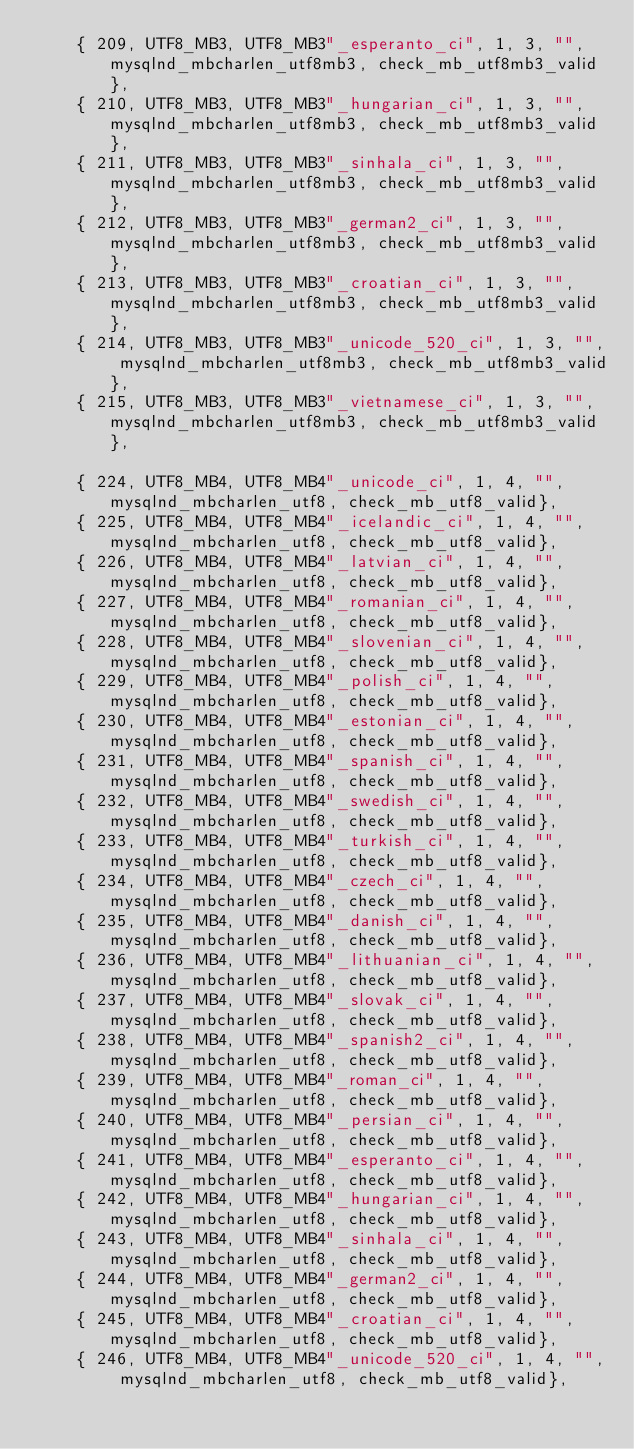Convert code to text. <code><loc_0><loc_0><loc_500><loc_500><_C_>	{ 209, UTF8_MB3, UTF8_MB3"_esperanto_ci", 1, 3, "", mysqlnd_mbcharlen_utf8mb3, check_mb_utf8mb3_valid},
	{ 210, UTF8_MB3, UTF8_MB3"_hungarian_ci", 1, 3, "", mysqlnd_mbcharlen_utf8mb3, check_mb_utf8mb3_valid},
	{ 211, UTF8_MB3, UTF8_MB3"_sinhala_ci", 1, 3, "", mysqlnd_mbcharlen_utf8mb3, check_mb_utf8mb3_valid},
	{ 212, UTF8_MB3, UTF8_MB3"_german2_ci", 1, 3, "", mysqlnd_mbcharlen_utf8mb3, check_mb_utf8mb3_valid},
	{ 213, UTF8_MB3, UTF8_MB3"_croatian_ci", 1, 3, "", mysqlnd_mbcharlen_utf8mb3, check_mb_utf8mb3_valid},
	{ 214, UTF8_MB3, UTF8_MB3"_unicode_520_ci", 1, 3, "", mysqlnd_mbcharlen_utf8mb3, check_mb_utf8mb3_valid},
	{ 215, UTF8_MB3, UTF8_MB3"_vietnamese_ci", 1, 3, "", mysqlnd_mbcharlen_utf8mb3, check_mb_utf8mb3_valid},

	{ 224, UTF8_MB4, UTF8_MB4"_unicode_ci", 1, 4, "", mysqlnd_mbcharlen_utf8, check_mb_utf8_valid},
	{ 225, UTF8_MB4, UTF8_MB4"_icelandic_ci", 1, 4, "", mysqlnd_mbcharlen_utf8, check_mb_utf8_valid},
	{ 226, UTF8_MB4, UTF8_MB4"_latvian_ci", 1, 4, "", mysqlnd_mbcharlen_utf8, check_mb_utf8_valid},
	{ 227, UTF8_MB4, UTF8_MB4"_romanian_ci", 1, 4, "", mysqlnd_mbcharlen_utf8, check_mb_utf8_valid},
	{ 228, UTF8_MB4, UTF8_MB4"_slovenian_ci", 1, 4, "", mysqlnd_mbcharlen_utf8, check_mb_utf8_valid},
	{ 229, UTF8_MB4, UTF8_MB4"_polish_ci", 1, 4, "", mysqlnd_mbcharlen_utf8, check_mb_utf8_valid},
	{ 230, UTF8_MB4, UTF8_MB4"_estonian_ci", 1, 4, "", mysqlnd_mbcharlen_utf8, check_mb_utf8_valid},
	{ 231, UTF8_MB4, UTF8_MB4"_spanish_ci", 1, 4, "", mysqlnd_mbcharlen_utf8, check_mb_utf8_valid},
	{ 232, UTF8_MB4, UTF8_MB4"_swedish_ci", 1, 4, "", mysqlnd_mbcharlen_utf8, check_mb_utf8_valid},
	{ 233, UTF8_MB4, UTF8_MB4"_turkish_ci", 1, 4, "", mysqlnd_mbcharlen_utf8, check_mb_utf8_valid},
	{ 234, UTF8_MB4, UTF8_MB4"_czech_ci", 1, 4, "", mysqlnd_mbcharlen_utf8, check_mb_utf8_valid},
	{ 235, UTF8_MB4, UTF8_MB4"_danish_ci", 1, 4, "", mysqlnd_mbcharlen_utf8, check_mb_utf8_valid},
	{ 236, UTF8_MB4, UTF8_MB4"_lithuanian_ci", 1, 4, "", mysqlnd_mbcharlen_utf8, check_mb_utf8_valid},
	{ 237, UTF8_MB4, UTF8_MB4"_slovak_ci", 1, 4, "", mysqlnd_mbcharlen_utf8, check_mb_utf8_valid},
	{ 238, UTF8_MB4, UTF8_MB4"_spanish2_ci", 1, 4, "", mysqlnd_mbcharlen_utf8, check_mb_utf8_valid},
	{ 239, UTF8_MB4, UTF8_MB4"_roman_ci", 1, 4, "", mysqlnd_mbcharlen_utf8, check_mb_utf8_valid},
	{ 240, UTF8_MB4, UTF8_MB4"_persian_ci", 1, 4, "", mysqlnd_mbcharlen_utf8, check_mb_utf8_valid},
	{ 241, UTF8_MB4, UTF8_MB4"_esperanto_ci", 1, 4, "", mysqlnd_mbcharlen_utf8, check_mb_utf8_valid},
	{ 242, UTF8_MB4, UTF8_MB4"_hungarian_ci", 1, 4, "", mysqlnd_mbcharlen_utf8, check_mb_utf8_valid},
	{ 243, UTF8_MB4, UTF8_MB4"_sinhala_ci", 1, 4, "", mysqlnd_mbcharlen_utf8, check_mb_utf8_valid},
	{ 244, UTF8_MB4, UTF8_MB4"_german2_ci", 1, 4, "", mysqlnd_mbcharlen_utf8, check_mb_utf8_valid},
	{ 245, UTF8_MB4, UTF8_MB4"_croatian_ci", 1, 4, "", mysqlnd_mbcharlen_utf8, check_mb_utf8_valid},
	{ 246, UTF8_MB4, UTF8_MB4"_unicode_520_ci", 1, 4, "", mysqlnd_mbcharlen_utf8, check_mb_utf8_valid},</code> 